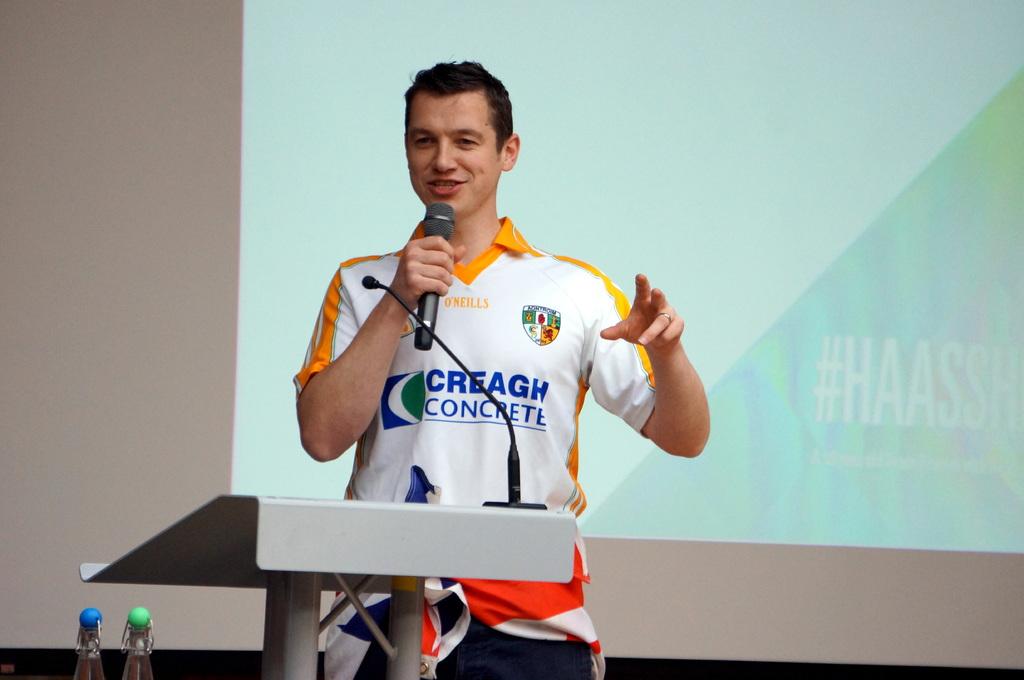What company is he woth?
Your answer should be compact. Creagh concrete. What does his shirt say?
Keep it short and to the point. Creagh concrete. 